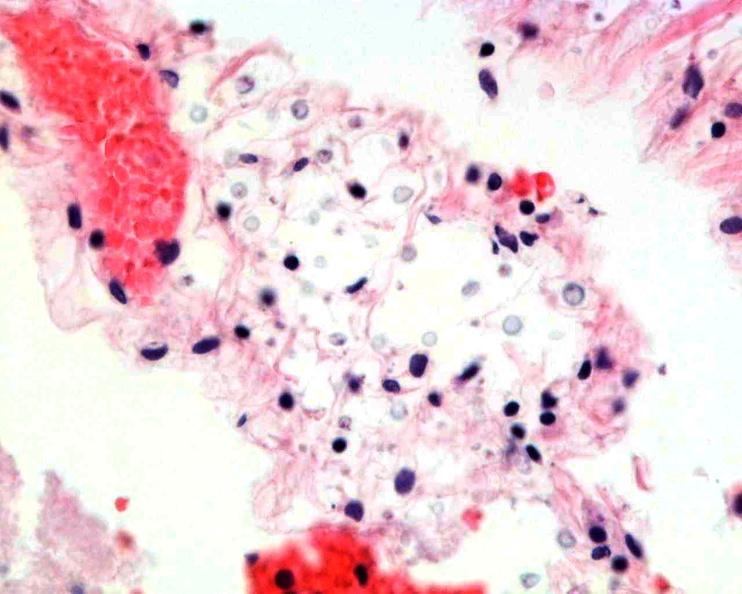does abdomen show brain, cryptococcal meningitis?
Answer the question using a single word or phrase. No 